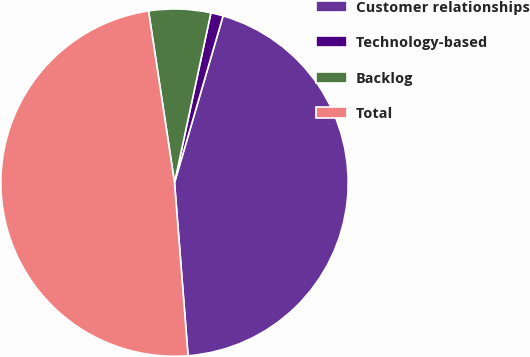Convert chart to OTSL. <chart><loc_0><loc_0><loc_500><loc_500><pie_chart><fcel>Customer relationships<fcel>Technology-based<fcel>Backlog<fcel>Total<nl><fcel>44.25%<fcel>1.15%<fcel>5.75%<fcel>48.85%<nl></chart> 